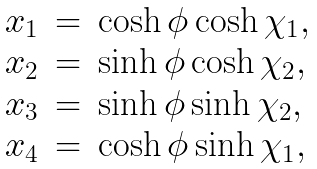Convert formula to latex. <formula><loc_0><loc_0><loc_500><loc_500>\begin{array} { r c l } x _ { 1 } & = & \cosh \phi \cosh \chi _ { 1 } , \\ x _ { 2 } & = & \sinh \phi \cosh \chi _ { 2 } , \\ x _ { 3 } & = & \sinh \phi \sinh \chi _ { 2 } , \\ x _ { 4 } & = & \cosh \phi \sinh \chi _ { 1 } , \end{array}</formula> 